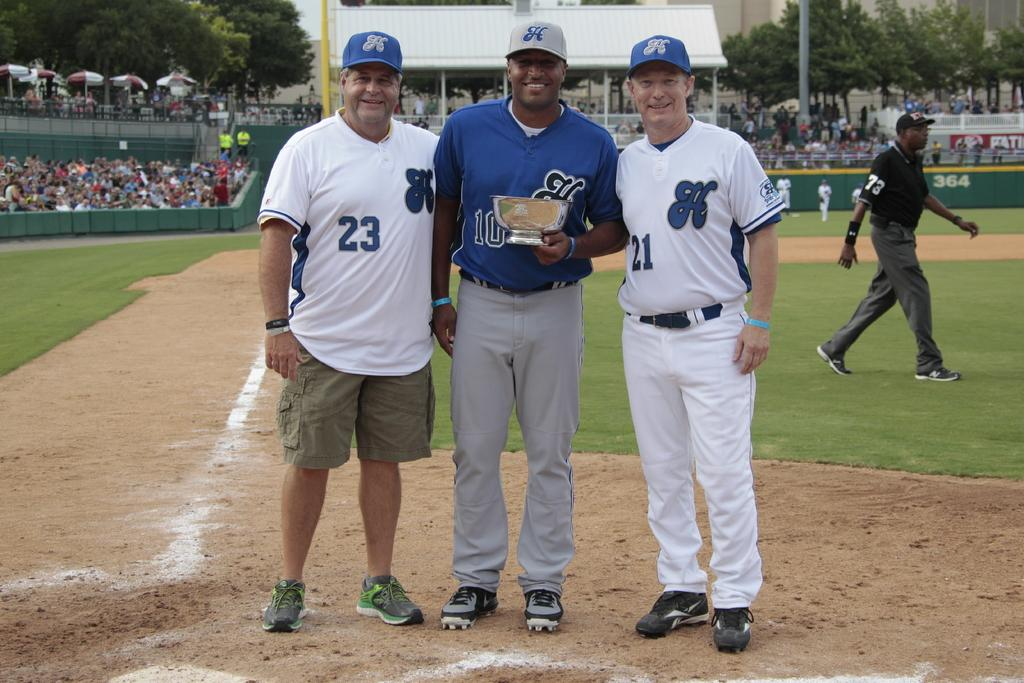Provide a one-sentence caption for the provided image. Men posing for a photo with one wearing the number 23. 